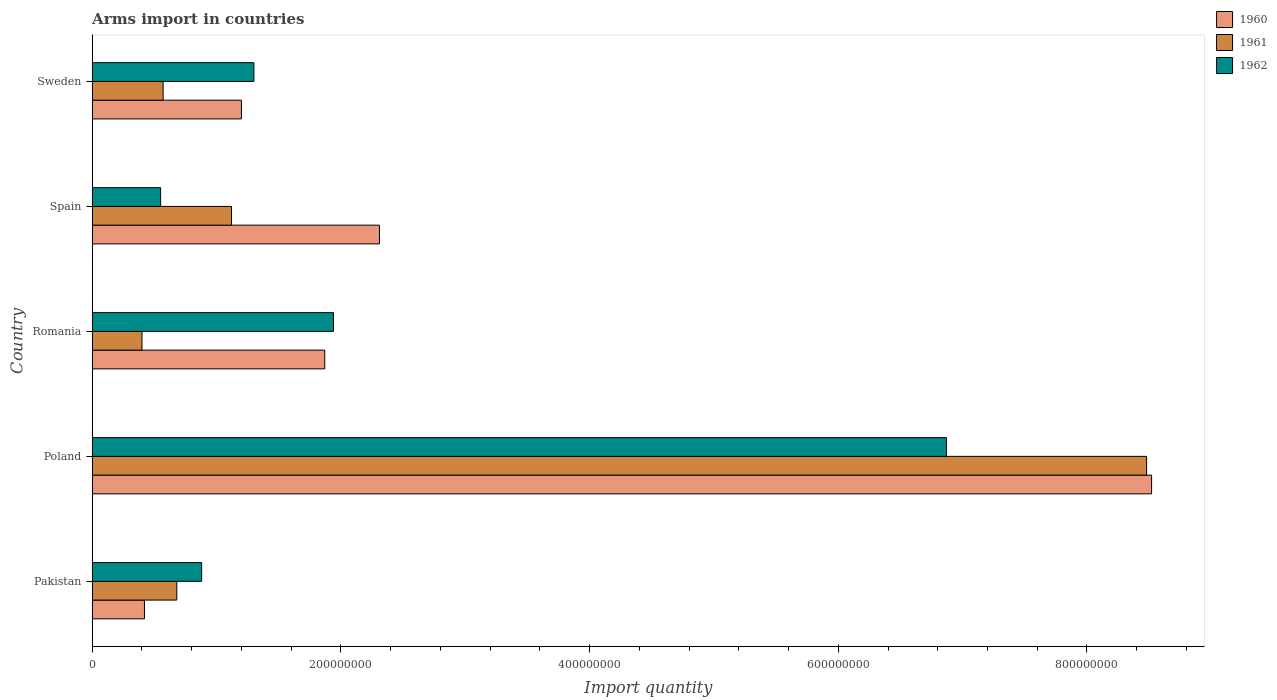How many different coloured bars are there?
Ensure brevity in your answer.  3. How many groups of bars are there?
Ensure brevity in your answer.  5. Are the number of bars per tick equal to the number of legend labels?
Give a very brief answer. Yes. Are the number of bars on each tick of the Y-axis equal?
Your answer should be compact. Yes. What is the label of the 3rd group of bars from the top?
Your response must be concise. Romania. What is the total arms import in 1960 in Pakistan?
Offer a terse response. 4.20e+07. Across all countries, what is the maximum total arms import in 1962?
Offer a very short reply. 6.87e+08. Across all countries, what is the minimum total arms import in 1962?
Offer a very short reply. 5.50e+07. In which country was the total arms import in 1960 maximum?
Your answer should be very brief. Poland. In which country was the total arms import in 1961 minimum?
Your response must be concise. Romania. What is the total total arms import in 1962 in the graph?
Your answer should be compact. 1.15e+09. What is the difference between the total arms import in 1960 in Pakistan and that in Romania?
Provide a short and direct response. -1.45e+08. What is the difference between the total arms import in 1961 in Pakistan and the total arms import in 1960 in Sweden?
Offer a terse response. -5.20e+07. What is the average total arms import in 1961 per country?
Make the answer very short. 2.25e+08. What is the difference between the total arms import in 1962 and total arms import in 1961 in Sweden?
Your answer should be compact. 7.30e+07. In how many countries, is the total arms import in 1960 greater than 640000000 ?
Provide a short and direct response. 1. What is the ratio of the total arms import in 1960 in Pakistan to that in Spain?
Your response must be concise. 0.18. What is the difference between the highest and the second highest total arms import in 1960?
Your response must be concise. 6.21e+08. What is the difference between the highest and the lowest total arms import in 1960?
Ensure brevity in your answer.  8.10e+08. In how many countries, is the total arms import in 1960 greater than the average total arms import in 1960 taken over all countries?
Make the answer very short. 1. Is the sum of the total arms import in 1960 in Poland and Spain greater than the maximum total arms import in 1962 across all countries?
Your response must be concise. Yes. Is it the case that in every country, the sum of the total arms import in 1960 and total arms import in 1962 is greater than the total arms import in 1961?
Offer a terse response. Yes. How many bars are there?
Your answer should be very brief. 15. Are all the bars in the graph horizontal?
Provide a succinct answer. Yes. What is the difference between two consecutive major ticks on the X-axis?
Ensure brevity in your answer.  2.00e+08. Does the graph contain any zero values?
Keep it short and to the point. No. Does the graph contain grids?
Give a very brief answer. No. How many legend labels are there?
Your answer should be compact. 3. How are the legend labels stacked?
Offer a very short reply. Vertical. What is the title of the graph?
Keep it short and to the point. Arms import in countries. What is the label or title of the X-axis?
Give a very brief answer. Import quantity. What is the label or title of the Y-axis?
Ensure brevity in your answer.  Country. What is the Import quantity of 1960 in Pakistan?
Provide a short and direct response. 4.20e+07. What is the Import quantity in 1961 in Pakistan?
Make the answer very short. 6.80e+07. What is the Import quantity in 1962 in Pakistan?
Provide a succinct answer. 8.80e+07. What is the Import quantity of 1960 in Poland?
Your answer should be very brief. 8.52e+08. What is the Import quantity in 1961 in Poland?
Provide a succinct answer. 8.48e+08. What is the Import quantity in 1962 in Poland?
Your answer should be compact. 6.87e+08. What is the Import quantity of 1960 in Romania?
Give a very brief answer. 1.87e+08. What is the Import quantity in 1961 in Romania?
Offer a very short reply. 4.00e+07. What is the Import quantity of 1962 in Romania?
Ensure brevity in your answer.  1.94e+08. What is the Import quantity of 1960 in Spain?
Provide a succinct answer. 2.31e+08. What is the Import quantity of 1961 in Spain?
Provide a succinct answer. 1.12e+08. What is the Import quantity of 1962 in Spain?
Provide a succinct answer. 5.50e+07. What is the Import quantity in 1960 in Sweden?
Your answer should be very brief. 1.20e+08. What is the Import quantity of 1961 in Sweden?
Make the answer very short. 5.70e+07. What is the Import quantity of 1962 in Sweden?
Make the answer very short. 1.30e+08. Across all countries, what is the maximum Import quantity of 1960?
Give a very brief answer. 8.52e+08. Across all countries, what is the maximum Import quantity of 1961?
Keep it short and to the point. 8.48e+08. Across all countries, what is the maximum Import quantity of 1962?
Provide a short and direct response. 6.87e+08. Across all countries, what is the minimum Import quantity of 1960?
Ensure brevity in your answer.  4.20e+07. Across all countries, what is the minimum Import quantity in 1961?
Offer a very short reply. 4.00e+07. Across all countries, what is the minimum Import quantity of 1962?
Make the answer very short. 5.50e+07. What is the total Import quantity in 1960 in the graph?
Your answer should be very brief. 1.43e+09. What is the total Import quantity of 1961 in the graph?
Make the answer very short. 1.12e+09. What is the total Import quantity of 1962 in the graph?
Make the answer very short. 1.15e+09. What is the difference between the Import quantity in 1960 in Pakistan and that in Poland?
Offer a terse response. -8.10e+08. What is the difference between the Import quantity of 1961 in Pakistan and that in Poland?
Make the answer very short. -7.80e+08. What is the difference between the Import quantity in 1962 in Pakistan and that in Poland?
Provide a short and direct response. -5.99e+08. What is the difference between the Import quantity of 1960 in Pakistan and that in Romania?
Make the answer very short. -1.45e+08. What is the difference between the Import quantity in 1961 in Pakistan and that in Romania?
Offer a very short reply. 2.80e+07. What is the difference between the Import quantity in 1962 in Pakistan and that in Romania?
Offer a very short reply. -1.06e+08. What is the difference between the Import quantity in 1960 in Pakistan and that in Spain?
Your answer should be compact. -1.89e+08. What is the difference between the Import quantity in 1961 in Pakistan and that in Spain?
Your response must be concise. -4.40e+07. What is the difference between the Import quantity of 1962 in Pakistan and that in Spain?
Offer a terse response. 3.30e+07. What is the difference between the Import quantity in 1960 in Pakistan and that in Sweden?
Your response must be concise. -7.80e+07. What is the difference between the Import quantity in 1961 in Pakistan and that in Sweden?
Make the answer very short. 1.10e+07. What is the difference between the Import quantity in 1962 in Pakistan and that in Sweden?
Provide a succinct answer. -4.20e+07. What is the difference between the Import quantity of 1960 in Poland and that in Romania?
Provide a short and direct response. 6.65e+08. What is the difference between the Import quantity of 1961 in Poland and that in Romania?
Ensure brevity in your answer.  8.08e+08. What is the difference between the Import quantity in 1962 in Poland and that in Romania?
Offer a terse response. 4.93e+08. What is the difference between the Import quantity in 1960 in Poland and that in Spain?
Ensure brevity in your answer.  6.21e+08. What is the difference between the Import quantity in 1961 in Poland and that in Spain?
Your answer should be very brief. 7.36e+08. What is the difference between the Import quantity in 1962 in Poland and that in Spain?
Your response must be concise. 6.32e+08. What is the difference between the Import quantity in 1960 in Poland and that in Sweden?
Offer a very short reply. 7.32e+08. What is the difference between the Import quantity in 1961 in Poland and that in Sweden?
Ensure brevity in your answer.  7.91e+08. What is the difference between the Import quantity of 1962 in Poland and that in Sweden?
Your answer should be very brief. 5.57e+08. What is the difference between the Import quantity in 1960 in Romania and that in Spain?
Your answer should be very brief. -4.40e+07. What is the difference between the Import quantity of 1961 in Romania and that in Spain?
Your response must be concise. -7.20e+07. What is the difference between the Import quantity in 1962 in Romania and that in Spain?
Offer a terse response. 1.39e+08. What is the difference between the Import quantity in 1960 in Romania and that in Sweden?
Give a very brief answer. 6.70e+07. What is the difference between the Import quantity in 1961 in Romania and that in Sweden?
Make the answer very short. -1.70e+07. What is the difference between the Import quantity of 1962 in Romania and that in Sweden?
Your answer should be compact. 6.40e+07. What is the difference between the Import quantity of 1960 in Spain and that in Sweden?
Give a very brief answer. 1.11e+08. What is the difference between the Import quantity in 1961 in Spain and that in Sweden?
Give a very brief answer. 5.50e+07. What is the difference between the Import quantity in 1962 in Spain and that in Sweden?
Ensure brevity in your answer.  -7.50e+07. What is the difference between the Import quantity in 1960 in Pakistan and the Import quantity in 1961 in Poland?
Your answer should be very brief. -8.06e+08. What is the difference between the Import quantity in 1960 in Pakistan and the Import quantity in 1962 in Poland?
Your response must be concise. -6.45e+08. What is the difference between the Import quantity in 1961 in Pakistan and the Import quantity in 1962 in Poland?
Give a very brief answer. -6.19e+08. What is the difference between the Import quantity in 1960 in Pakistan and the Import quantity in 1962 in Romania?
Offer a very short reply. -1.52e+08. What is the difference between the Import quantity in 1961 in Pakistan and the Import quantity in 1962 in Romania?
Provide a short and direct response. -1.26e+08. What is the difference between the Import quantity of 1960 in Pakistan and the Import quantity of 1961 in Spain?
Provide a succinct answer. -7.00e+07. What is the difference between the Import quantity of 1960 in Pakistan and the Import quantity of 1962 in Spain?
Provide a short and direct response. -1.30e+07. What is the difference between the Import quantity of 1961 in Pakistan and the Import quantity of 1962 in Spain?
Your answer should be very brief. 1.30e+07. What is the difference between the Import quantity of 1960 in Pakistan and the Import quantity of 1961 in Sweden?
Make the answer very short. -1.50e+07. What is the difference between the Import quantity in 1960 in Pakistan and the Import quantity in 1962 in Sweden?
Ensure brevity in your answer.  -8.80e+07. What is the difference between the Import quantity in 1961 in Pakistan and the Import quantity in 1962 in Sweden?
Your answer should be compact. -6.20e+07. What is the difference between the Import quantity in 1960 in Poland and the Import quantity in 1961 in Romania?
Your answer should be very brief. 8.12e+08. What is the difference between the Import quantity in 1960 in Poland and the Import quantity in 1962 in Romania?
Ensure brevity in your answer.  6.58e+08. What is the difference between the Import quantity in 1961 in Poland and the Import quantity in 1962 in Romania?
Give a very brief answer. 6.54e+08. What is the difference between the Import quantity of 1960 in Poland and the Import quantity of 1961 in Spain?
Your answer should be compact. 7.40e+08. What is the difference between the Import quantity of 1960 in Poland and the Import quantity of 1962 in Spain?
Provide a succinct answer. 7.97e+08. What is the difference between the Import quantity in 1961 in Poland and the Import quantity in 1962 in Spain?
Ensure brevity in your answer.  7.93e+08. What is the difference between the Import quantity of 1960 in Poland and the Import quantity of 1961 in Sweden?
Your answer should be compact. 7.95e+08. What is the difference between the Import quantity in 1960 in Poland and the Import quantity in 1962 in Sweden?
Give a very brief answer. 7.22e+08. What is the difference between the Import quantity of 1961 in Poland and the Import quantity of 1962 in Sweden?
Offer a very short reply. 7.18e+08. What is the difference between the Import quantity in 1960 in Romania and the Import quantity in 1961 in Spain?
Your response must be concise. 7.50e+07. What is the difference between the Import quantity in 1960 in Romania and the Import quantity in 1962 in Spain?
Make the answer very short. 1.32e+08. What is the difference between the Import quantity of 1961 in Romania and the Import quantity of 1962 in Spain?
Ensure brevity in your answer.  -1.50e+07. What is the difference between the Import quantity of 1960 in Romania and the Import quantity of 1961 in Sweden?
Ensure brevity in your answer.  1.30e+08. What is the difference between the Import quantity in 1960 in Romania and the Import quantity in 1962 in Sweden?
Give a very brief answer. 5.70e+07. What is the difference between the Import quantity in 1961 in Romania and the Import quantity in 1962 in Sweden?
Make the answer very short. -9.00e+07. What is the difference between the Import quantity in 1960 in Spain and the Import quantity in 1961 in Sweden?
Your response must be concise. 1.74e+08. What is the difference between the Import quantity of 1960 in Spain and the Import quantity of 1962 in Sweden?
Provide a short and direct response. 1.01e+08. What is the difference between the Import quantity of 1961 in Spain and the Import quantity of 1962 in Sweden?
Give a very brief answer. -1.80e+07. What is the average Import quantity in 1960 per country?
Your answer should be compact. 2.86e+08. What is the average Import quantity in 1961 per country?
Keep it short and to the point. 2.25e+08. What is the average Import quantity in 1962 per country?
Offer a terse response. 2.31e+08. What is the difference between the Import quantity in 1960 and Import quantity in 1961 in Pakistan?
Make the answer very short. -2.60e+07. What is the difference between the Import quantity in 1960 and Import quantity in 1962 in Pakistan?
Provide a short and direct response. -4.60e+07. What is the difference between the Import quantity of 1961 and Import quantity of 1962 in Pakistan?
Offer a very short reply. -2.00e+07. What is the difference between the Import quantity in 1960 and Import quantity in 1962 in Poland?
Give a very brief answer. 1.65e+08. What is the difference between the Import quantity in 1961 and Import quantity in 1962 in Poland?
Your answer should be very brief. 1.61e+08. What is the difference between the Import quantity in 1960 and Import quantity in 1961 in Romania?
Provide a succinct answer. 1.47e+08. What is the difference between the Import quantity in 1960 and Import quantity in 1962 in Romania?
Provide a short and direct response. -7.00e+06. What is the difference between the Import quantity of 1961 and Import quantity of 1962 in Romania?
Ensure brevity in your answer.  -1.54e+08. What is the difference between the Import quantity in 1960 and Import quantity in 1961 in Spain?
Your response must be concise. 1.19e+08. What is the difference between the Import quantity of 1960 and Import quantity of 1962 in Spain?
Keep it short and to the point. 1.76e+08. What is the difference between the Import quantity in 1961 and Import quantity in 1962 in Spain?
Your answer should be very brief. 5.70e+07. What is the difference between the Import quantity in 1960 and Import quantity in 1961 in Sweden?
Your answer should be very brief. 6.30e+07. What is the difference between the Import quantity of 1960 and Import quantity of 1962 in Sweden?
Your answer should be compact. -1.00e+07. What is the difference between the Import quantity of 1961 and Import quantity of 1962 in Sweden?
Make the answer very short. -7.30e+07. What is the ratio of the Import quantity in 1960 in Pakistan to that in Poland?
Make the answer very short. 0.05. What is the ratio of the Import quantity in 1961 in Pakistan to that in Poland?
Give a very brief answer. 0.08. What is the ratio of the Import quantity in 1962 in Pakistan to that in Poland?
Your answer should be compact. 0.13. What is the ratio of the Import quantity of 1960 in Pakistan to that in Romania?
Your answer should be very brief. 0.22. What is the ratio of the Import quantity in 1961 in Pakistan to that in Romania?
Your answer should be very brief. 1.7. What is the ratio of the Import quantity in 1962 in Pakistan to that in Romania?
Provide a succinct answer. 0.45. What is the ratio of the Import quantity of 1960 in Pakistan to that in Spain?
Your response must be concise. 0.18. What is the ratio of the Import quantity in 1961 in Pakistan to that in Spain?
Give a very brief answer. 0.61. What is the ratio of the Import quantity of 1962 in Pakistan to that in Spain?
Your answer should be compact. 1.6. What is the ratio of the Import quantity in 1961 in Pakistan to that in Sweden?
Your answer should be compact. 1.19. What is the ratio of the Import quantity of 1962 in Pakistan to that in Sweden?
Provide a succinct answer. 0.68. What is the ratio of the Import quantity of 1960 in Poland to that in Romania?
Your response must be concise. 4.56. What is the ratio of the Import quantity of 1961 in Poland to that in Romania?
Keep it short and to the point. 21.2. What is the ratio of the Import quantity of 1962 in Poland to that in Romania?
Ensure brevity in your answer.  3.54. What is the ratio of the Import quantity in 1960 in Poland to that in Spain?
Keep it short and to the point. 3.69. What is the ratio of the Import quantity in 1961 in Poland to that in Spain?
Ensure brevity in your answer.  7.57. What is the ratio of the Import quantity of 1962 in Poland to that in Spain?
Offer a very short reply. 12.49. What is the ratio of the Import quantity in 1960 in Poland to that in Sweden?
Your response must be concise. 7.1. What is the ratio of the Import quantity in 1961 in Poland to that in Sweden?
Your answer should be very brief. 14.88. What is the ratio of the Import quantity in 1962 in Poland to that in Sweden?
Your answer should be compact. 5.28. What is the ratio of the Import quantity in 1960 in Romania to that in Spain?
Offer a very short reply. 0.81. What is the ratio of the Import quantity in 1961 in Romania to that in Spain?
Keep it short and to the point. 0.36. What is the ratio of the Import quantity of 1962 in Romania to that in Spain?
Offer a very short reply. 3.53. What is the ratio of the Import quantity of 1960 in Romania to that in Sweden?
Ensure brevity in your answer.  1.56. What is the ratio of the Import quantity in 1961 in Romania to that in Sweden?
Offer a terse response. 0.7. What is the ratio of the Import quantity in 1962 in Romania to that in Sweden?
Your answer should be compact. 1.49. What is the ratio of the Import quantity in 1960 in Spain to that in Sweden?
Give a very brief answer. 1.93. What is the ratio of the Import quantity of 1961 in Spain to that in Sweden?
Offer a terse response. 1.96. What is the ratio of the Import quantity of 1962 in Spain to that in Sweden?
Your answer should be compact. 0.42. What is the difference between the highest and the second highest Import quantity in 1960?
Ensure brevity in your answer.  6.21e+08. What is the difference between the highest and the second highest Import quantity in 1961?
Your answer should be very brief. 7.36e+08. What is the difference between the highest and the second highest Import quantity in 1962?
Ensure brevity in your answer.  4.93e+08. What is the difference between the highest and the lowest Import quantity in 1960?
Your answer should be very brief. 8.10e+08. What is the difference between the highest and the lowest Import quantity in 1961?
Ensure brevity in your answer.  8.08e+08. What is the difference between the highest and the lowest Import quantity in 1962?
Ensure brevity in your answer.  6.32e+08. 